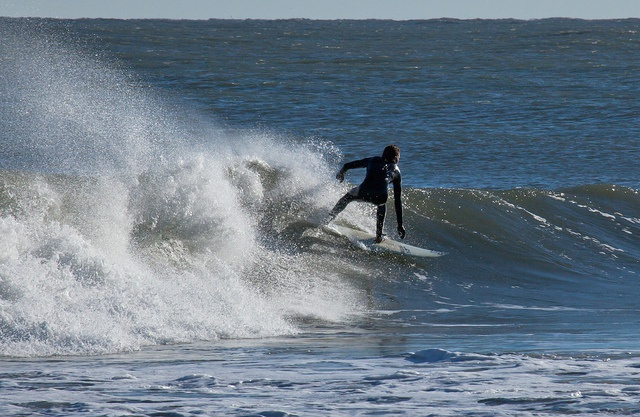Describe the objects in this image and their specific colors. I can see people in darkgray, black, gray, and blue tones and surfboard in darkgray, gray, blue, and darkblue tones in this image. 